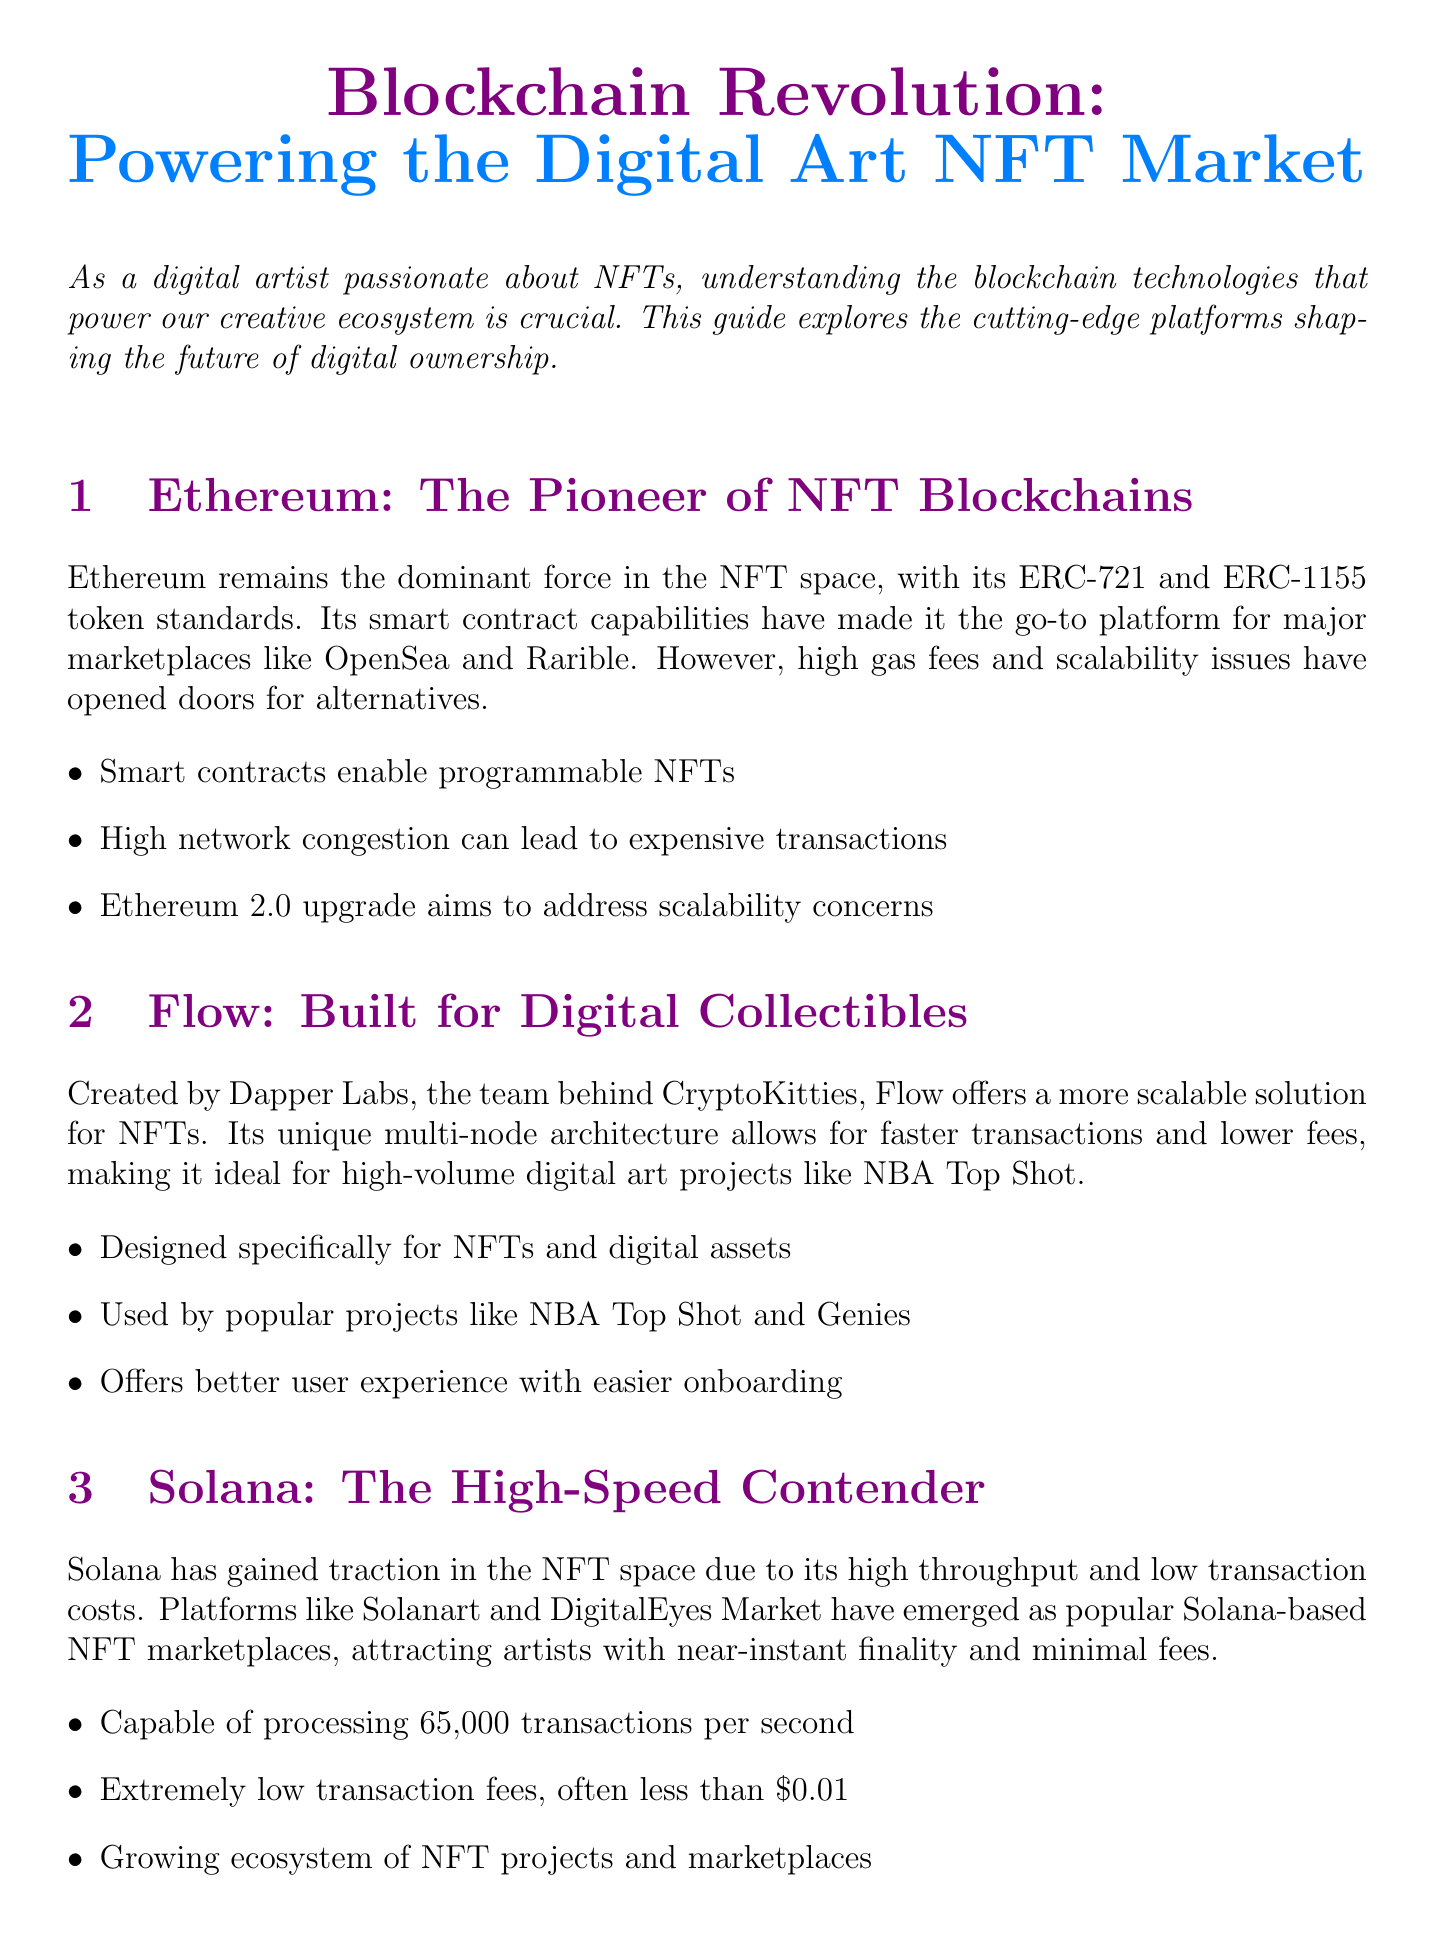What is the title of the newsletter? The title of the newsletter is stated at the beginning of the document.
Answer: Blockchain Revolution: Powering the Digital Art NFT Market Which token standards does Ethereum utilize? The document mentions the specific token standards associated with Ethereum.
Answer: ERC-721 and ERC-1155 What is the primary focus of Flow? The content discusses what Flow was built for regarding NFTs.
Answer: Digital Collectibles How many transactions per second can Solana process? The document outlines the processing capacity of the Solana blockchain.
Answer: 65,000 What consensus mechanism does Tezos use? The document specifies the type of consensus mechanism that Tezos employs.
Answer: Proof-of-Stake Which blockchain is mentioned as being environmentally friendly? The content describes Tezos's position in the market with regards to environmental impact.
Answer: Tezos What is the main advantage of using Polygon for NFTs? The document discusses the benefit of using Polygon in relation to Ethereum-based NFTs.
Answer: Cheaper transactions Name one NFT project mentioned that uses Flow. The document provides examples of projects utilizing the Flow blockchain.
Answer: NBA Top Shot Which platform is highlighted for being a low-cost option? The document emphasizes the transaction cost advantages of a specific blockchain.
Answer: Solana 